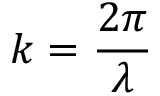<formula> <loc_0><loc_0><loc_500><loc_500>k = { \frac { 2 \pi } { \lambda } }</formula> 